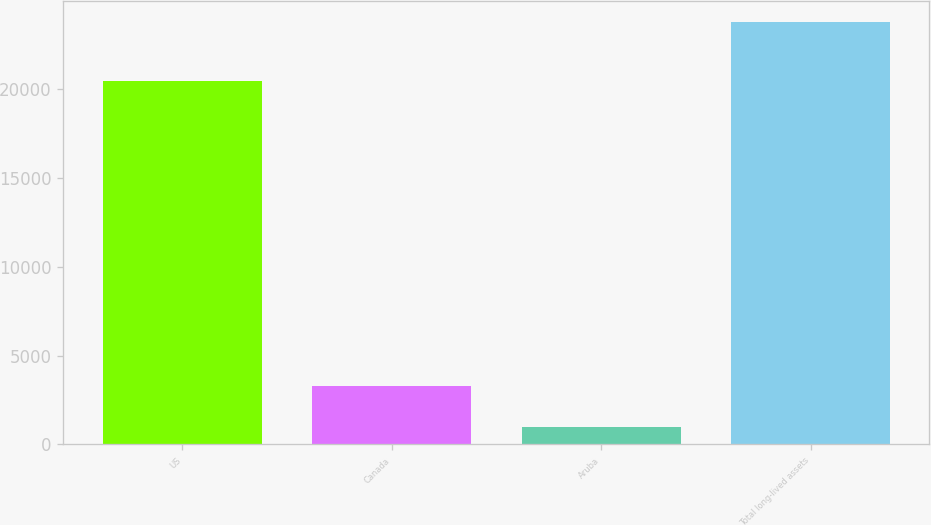<chart> <loc_0><loc_0><loc_500><loc_500><bar_chart><fcel>US<fcel>Canada<fcel>Aruba<fcel>Total long-lived assets<nl><fcel>20488<fcel>3260.6<fcel>981<fcel>23777<nl></chart> 